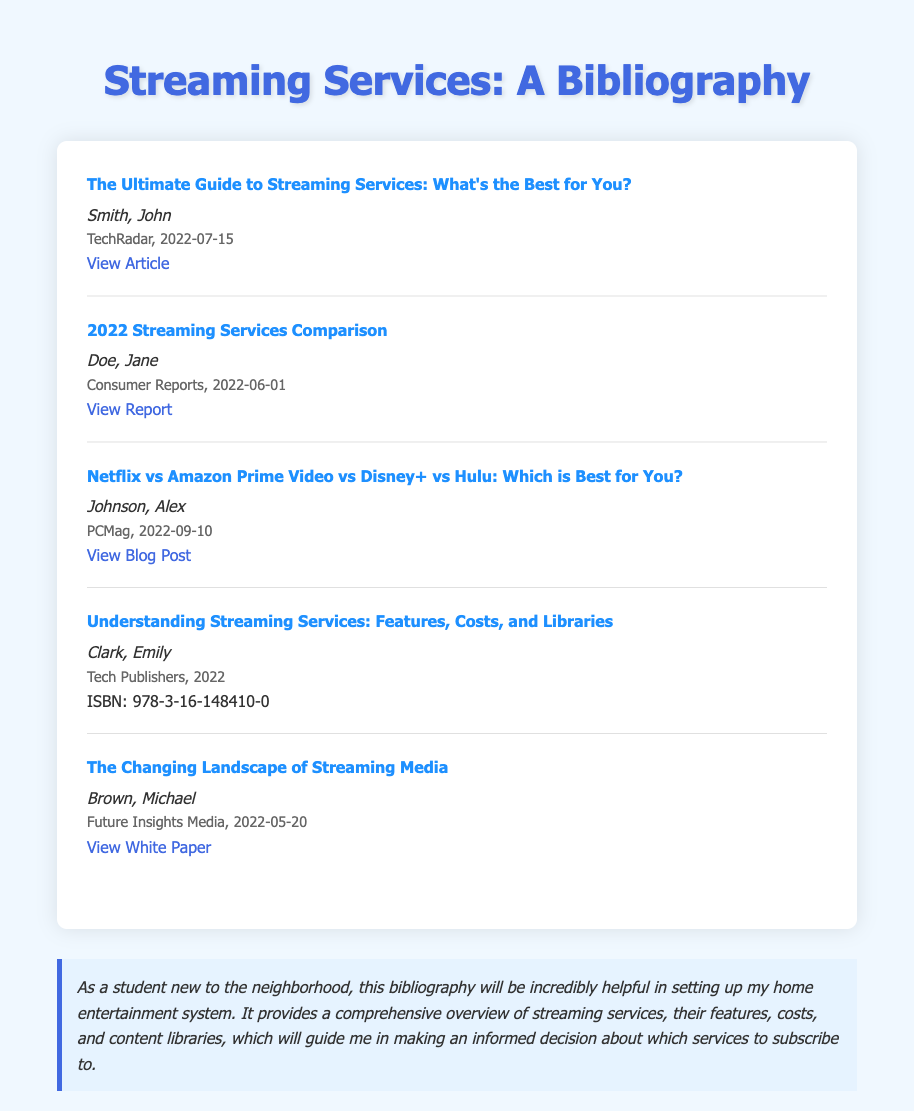What is the title of the first entry? The title of the first entry is listed in the document as "The Ultimate Guide to Streaming Services: What's the Best for You?"
Answer: The Ultimate Guide to Streaming Services: What's the Best for You? Who is the author of the second entry? The author's name for the second entry is provided directly in the document as Jane Doe.
Answer: Jane Doe What is the publication date of the fifth entry? The publication date for the fifth entry is specified in the document as May 20, 2022.
Answer: 2022-05-20 How many entries are there in the bibliography? The total number of entries can be counted directly from the document, which lists five distinct titles.
Answer: 5 Which organization published the fourth entry? The publisher of the fourth entry is identified in the document as Tech Publishers.
Answer: Tech Publishers What is the ISBN of the fourth entry? The ISBN for the fourth entry is explicitly mentioned in the document as 978-3-16-148410-0.
Answer: 978-3-16-148410-0 What type of document is this? This document is categorized and structured specifically as a bibliography.
Answer: Bibliography What color is the background of the document? The background color of the document is described as a light blue shade.
Answer: #f0f8ff 